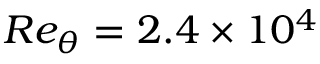Convert formula to latex. <formula><loc_0><loc_0><loc_500><loc_500>R e _ { \theta } = 2 . 4 \times 1 0 ^ { 4 }</formula> 